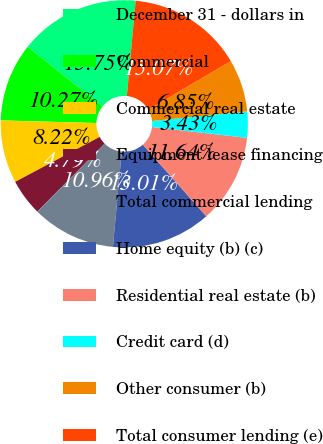Convert chart to OTSL. <chart><loc_0><loc_0><loc_500><loc_500><pie_chart><fcel>December 31 - dollars in<fcel>Commercial<fcel>Commercial real estate<fcel>Equipment lease financing<fcel>Total commercial lending<fcel>Home equity (b) (c)<fcel>Residential real estate (b)<fcel>Credit card (d)<fcel>Other consumer (b)<fcel>Total consumer lending (e)<nl><fcel>15.75%<fcel>10.27%<fcel>8.22%<fcel>4.79%<fcel>10.96%<fcel>13.01%<fcel>11.64%<fcel>3.43%<fcel>6.85%<fcel>15.07%<nl></chart> 